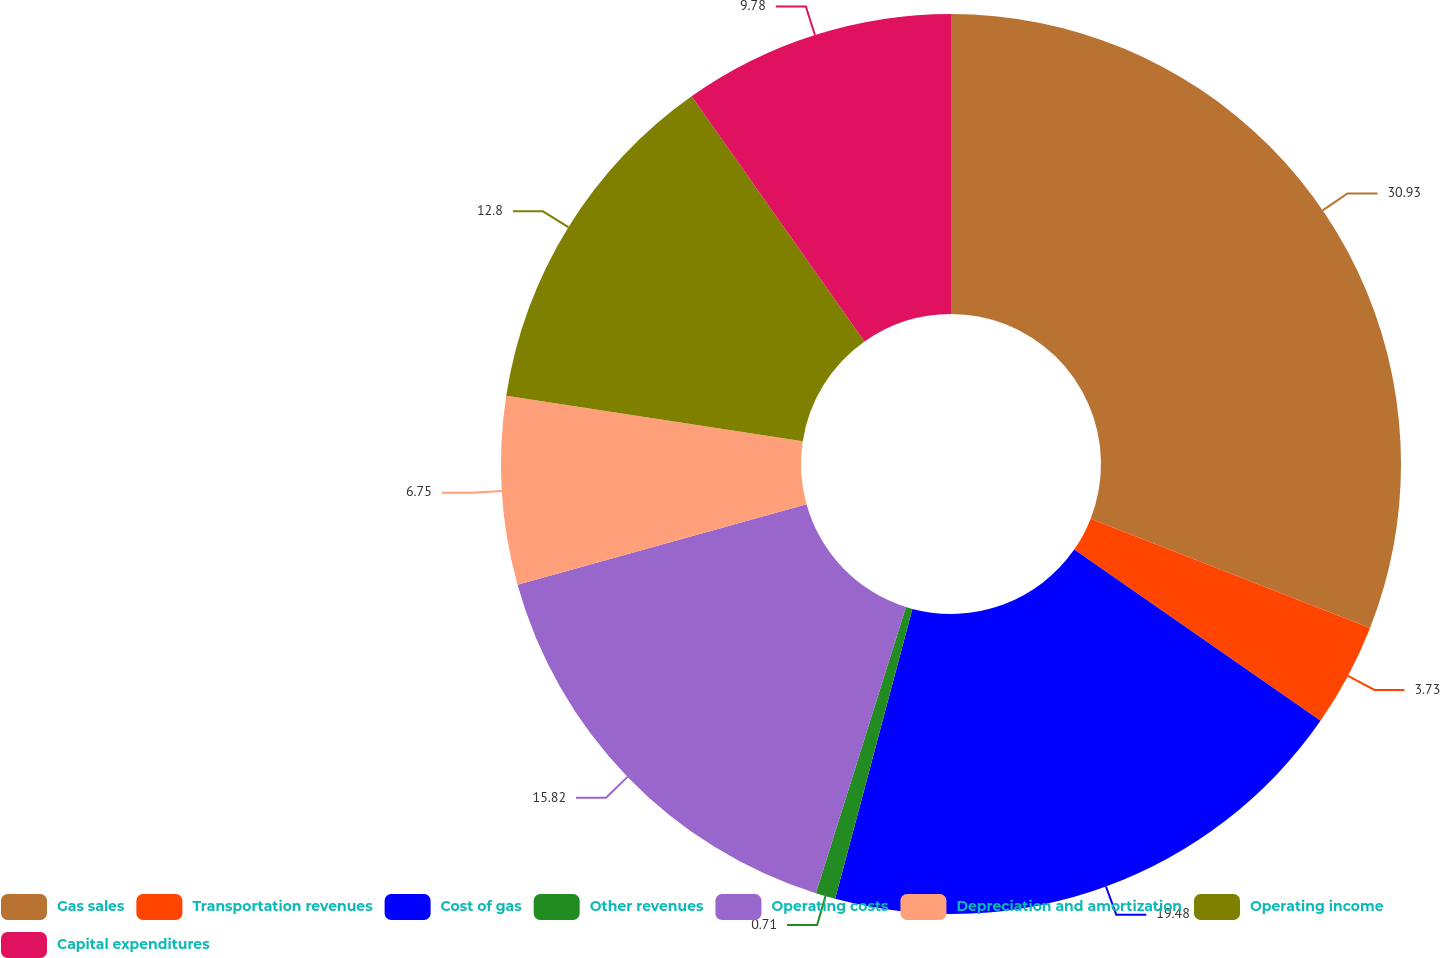<chart> <loc_0><loc_0><loc_500><loc_500><pie_chart><fcel>Gas sales<fcel>Transportation revenues<fcel>Cost of gas<fcel>Other revenues<fcel>Operating costs<fcel>Depreciation and amortization<fcel>Operating income<fcel>Capital expenditures<nl><fcel>30.94%<fcel>3.73%<fcel>19.48%<fcel>0.71%<fcel>15.82%<fcel>6.75%<fcel>12.8%<fcel>9.78%<nl></chart> 